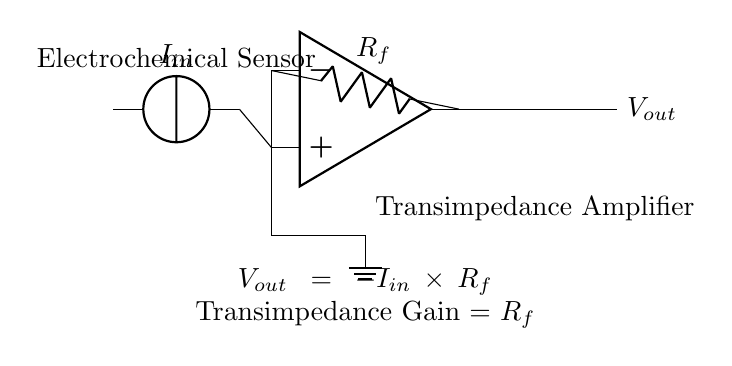What is the type of amplifier shown in the circuit? The circuit is a transimpedance amplifier, which converts current input from the sensor into a voltage output. This is identified by the presence of an operational amplifier with feedback components typically used for transimpedance applications.
Answer: transimpedance What does \( V_{out} \) represent in this circuit? \( V_{out} \) stands for the output voltage of the transimpedance amplifier, which is determined by the input current multiplied by the feedback resistor. This relationship is described by the equation shown in the circuit.
Answer: output voltage What is the role of \( R_f \) in this circuit? \( R_f \) is the feedback resistor that sets the transimpedance gain. The output voltage \( V_{out} \) is proportional to the input current \( I_{in} \) multiplied by this resistor, indicating its critical role in the conversion process.
Answer: feedback resistor What is the relationship between \( I_{in} \) and \( V_{out} \)? The relationship is described by the formula \( V_{out} = -I_{in} \times R_f \). This negative sign indicates that the output voltage is inversely related to the input current, which is a characteristic trait of inverting amplifiers.
Answer: negative proportionality How does this amplifier circuit improve the signal from the electrochemical sensor? The circuit converts a small current signal from the electrochemical sensor into a larger voltage signal, which increases the signal's magnitude and makes it more suitable for further processing or measurement. This conversion enhances the detectability of the sensor's output.
Answer: improves signal magnitude What happens if the value of \( R_f \) is increased? Increasing \( R_f \) will enhance the gain of the transimpedance amplifier, resulting in a larger output voltage for the same input current. This means that the circuit can better amplify weak signals from the sensor, making it more sensitive to changes.
Answer: larger output voltage What indicates that this circuit is designed for measuring signals from sensors? The presence of an electrochemical sensor represented by a current source indicates that the circuit is designed to handle inputs from sensing devices. The transimpedance amplifier is frequently used in applications requiring accurate measurements of small signals, especially in drug testing.
Answer: electrochemical sensor 